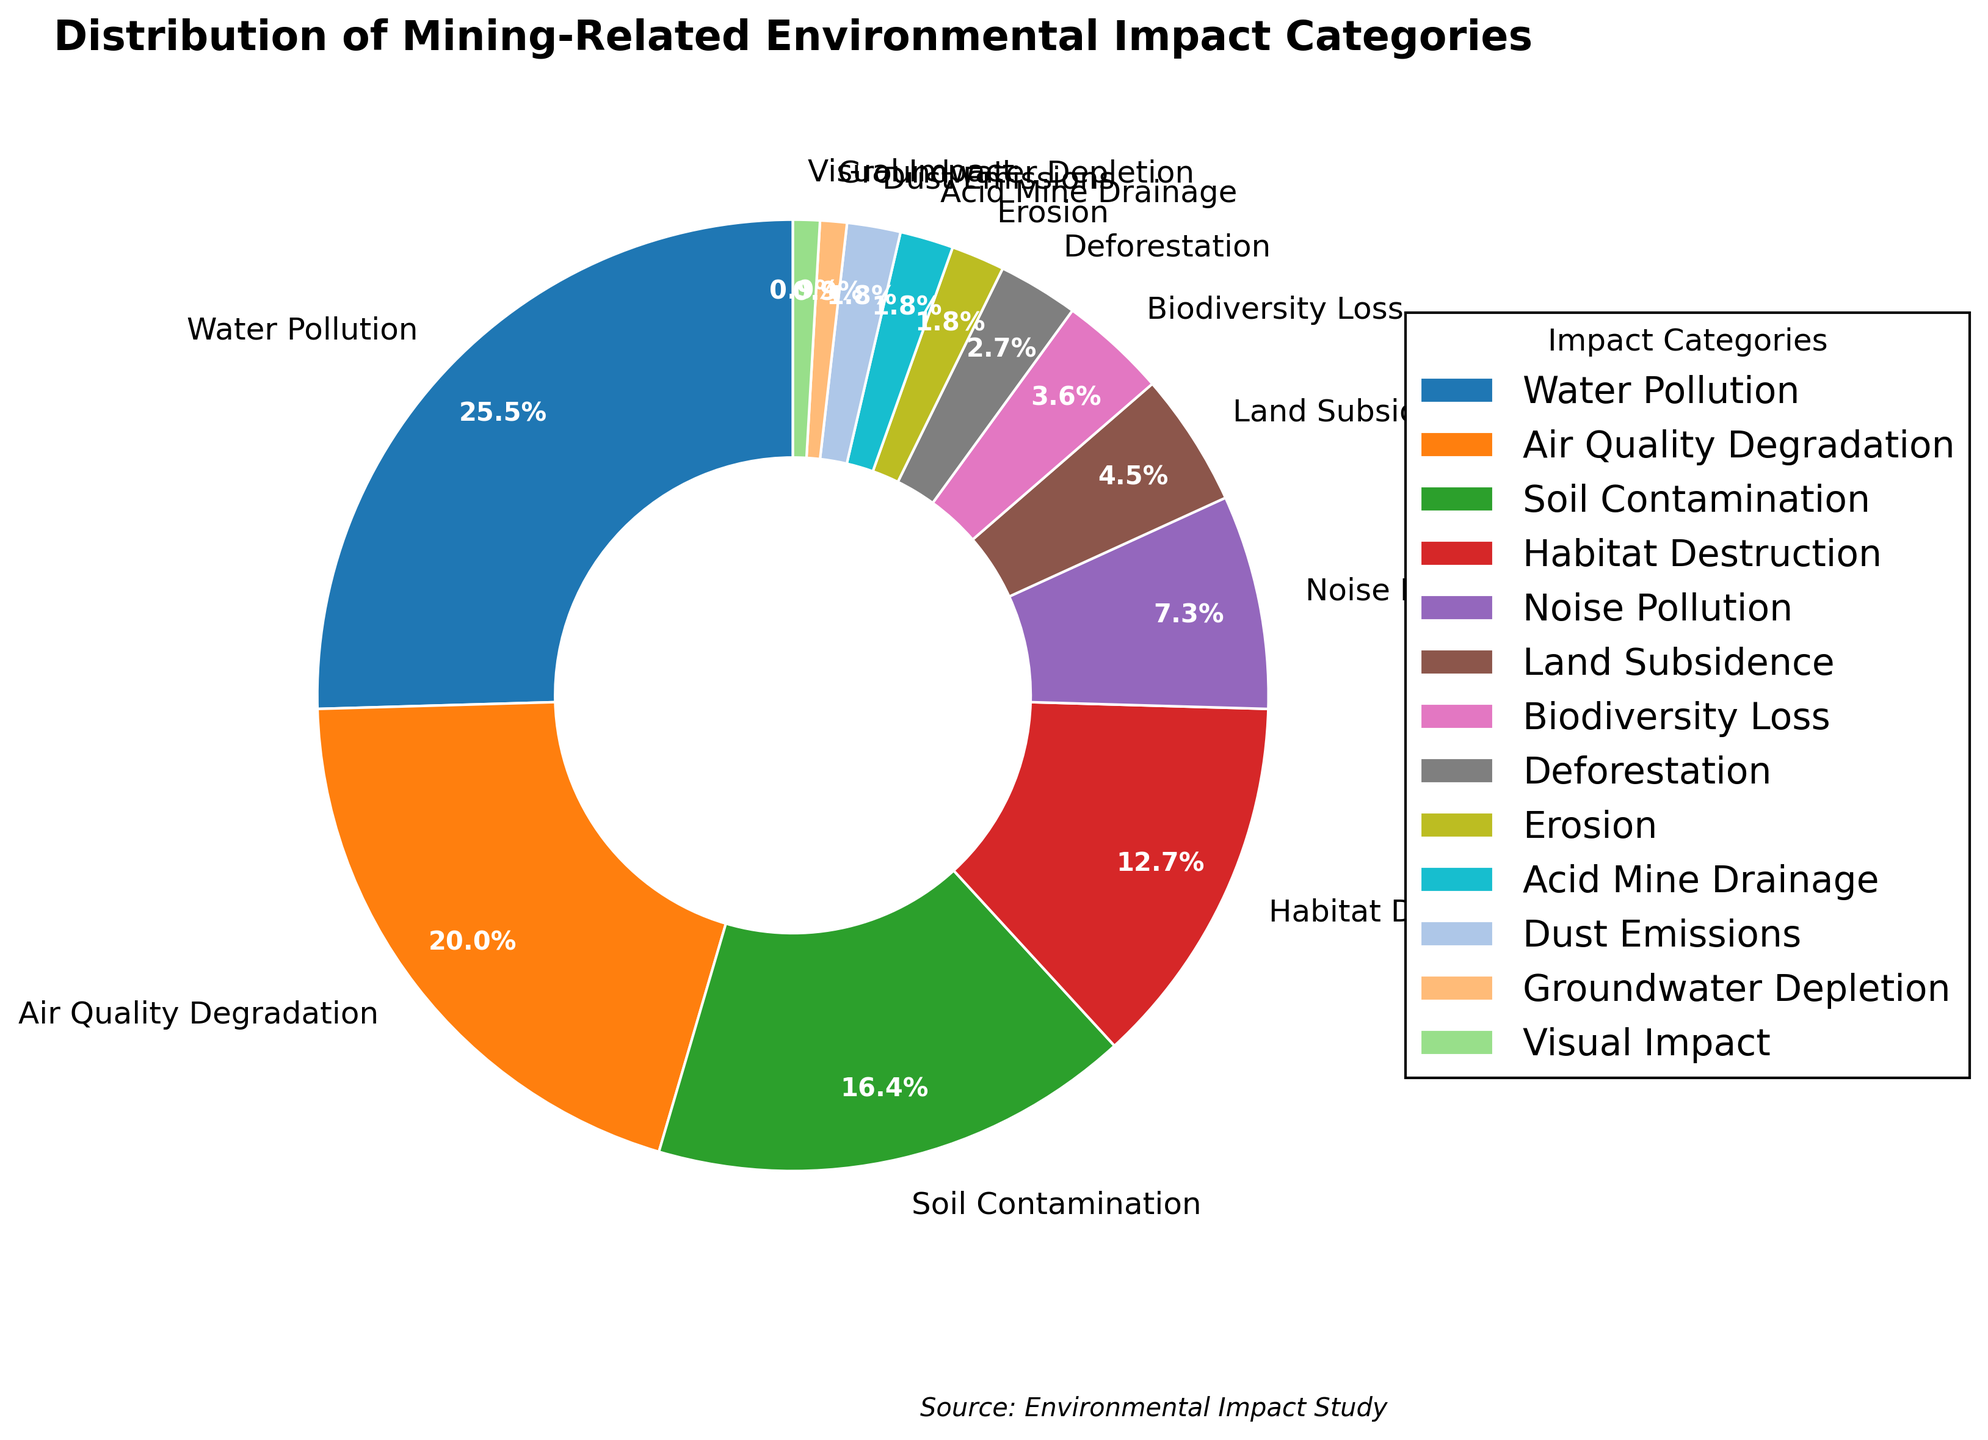Which category has the highest environmental impact? The pie chart shows that Water Pollution has the highest percentage at 28%.
Answer: Water Pollution What is the combined percentage of Soil Contamination and Habitat Destruction? According to the chart, Soil Contamination is at 18% and Habitat Destruction is at 14%. Adding these together results in 18% + 14% = 32%.
Answer: 32% Which categories have an equal percentage of environmental impact? The chart shows that Erosion, Acid Mine Drainage, and Dust Emissions each account for 2% of the impact.
Answer: Erosion, Acid Mine Drainage, Dust Emissions How much greater is the impact of Air Quality Degradation compared to Noise Pollution? Air Quality Degradation is at 22%, while Noise Pollution is at 8%. The difference is 22% - 8% = 14%.
Answer: 14% What is the percentage difference between Land Subsidence and Biodiversity Loss? Land Subsidence is at 5% and Biodiversity Loss is at 4%. The difference between these percentages is 5% - 4% = 1%.
Answer: 1% What is the total percentage of impacts that are below 5%? The categories below 5% are Land Subsidence (5%), Biodiversity Loss (4%), Deforestation (3%), Erosion (2%), Acid Mine Drainage (2%), Dust Emissions (2%), Groundwater Depletion (1%), and Visual Impact (1%). Adding them gives us 5% + 4% + 3% + 2% + 2% + 2% + 1% + 1% = 20%.
Answer: 20% Which two categories together make up a quarter of the total impact? Deforestation is at 3% and Biodiversity Loss is at 4%. Adding these together we get 3% + 4% = 7%. To find a sum that makes a quarter, let’s check other combinations. Soil Contamination (18%) + Biodiversity Loss (4%) = 22%. This is close, but Habitat Destruction (14%) + Noise Pollution (8%) = 22%. However, Water Pollution (28%) is closest alone at 28%. Therefore, no two categories exactly make up a quarter, but Soil Contamination and Habitat Destruction together get closer to a combined quarter.
Answer: None exactly; closest pairs are 22% Is the combined impact of Water Pollution and Air Quality Degradation more than half of the total impact? Water Pollution has 28% and Air Quality Degradation has 22%. Adding these gives 28% + 22% = 50%. Exactly half, not more than half.
Answer: No 